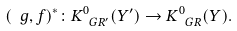Convert formula to latex. <formula><loc_0><loc_0><loc_500><loc_500>( \ g , f ) ^ { * } \colon K ^ { 0 } _ { \ G R ^ { \prime } } ( Y ^ { \prime } ) \to K ^ { 0 } _ { \ G R } ( Y ) .</formula> 